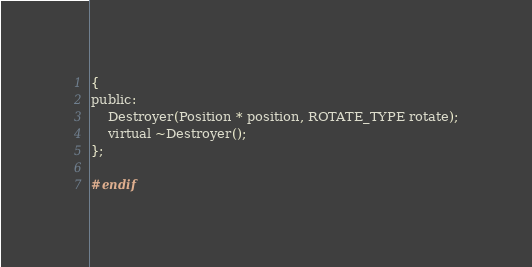<code> <loc_0><loc_0><loc_500><loc_500><_C_>{
public:
	Destroyer(Position * position, ROTATE_TYPE rotate);
	virtual ~Destroyer();
};

#endif
</code> 